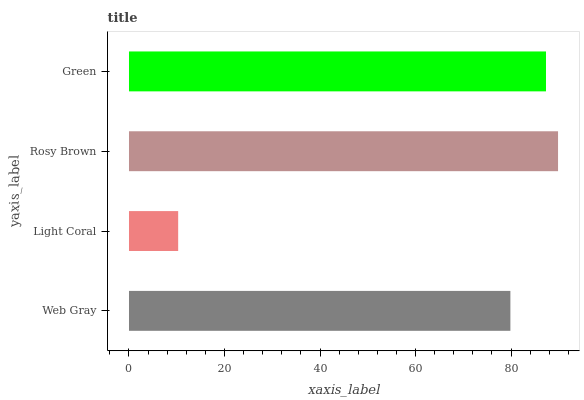Is Light Coral the minimum?
Answer yes or no. Yes. Is Rosy Brown the maximum?
Answer yes or no. Yes. Is Rosy Brown the minimum?
Answer yes or no. No. Is Light Coral the maximum?
Answer yes or no. No. Is Rosy Brown greater than Light Coral?
Answer yes or no. Yes. Is Light Coral less than Rosy Brown?
Answer yes or no. Yes. Is Light Coral greater than Rosy Brown?
Answer yes or no. No. Is Rosy Brown less than Light Coral?
Answer yes or no. No. Is Green the high median?
Answer yes or no. Yes. Is Web Gray the low median?
Answer yes or no. Yes. Is Rosy Brown the high median?
Answer yes or no. No. Is Green the low median?
Answer yes or no. No. 